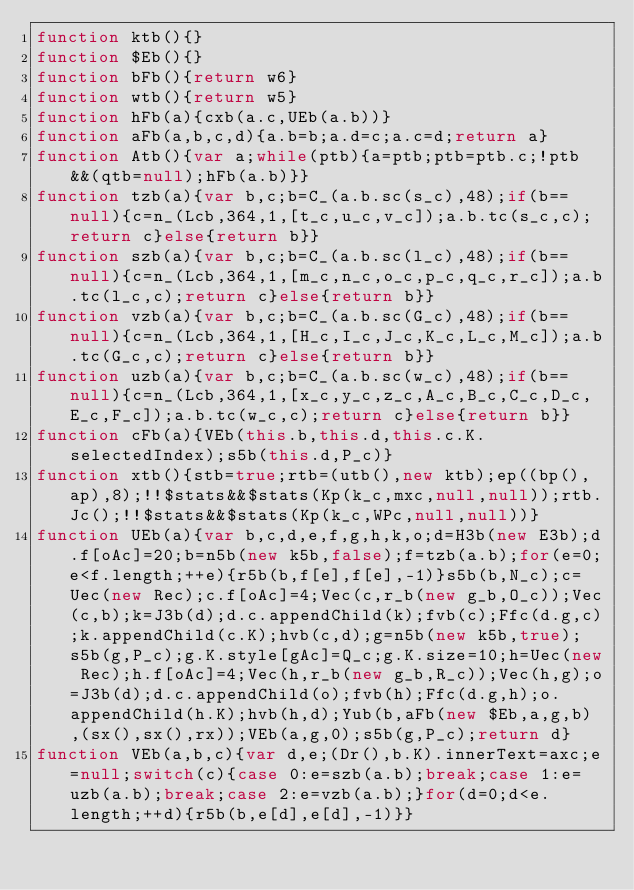Convert code to text. <code><loc_0><loc_0><loc_500><loc_500><_JavaScript_>function ktb(){}
function $Eb(){}
function bFb(){return w6}
function wtb(){return w5}
function hFb(a){cxb(a.c,UEb(a.b))}
function aFb(a,b,c,d){a.b=b;a.d=c;a.c=d;return a}
function Atb(){var a;while(ptb){a=ptb;ptb=ptb.c;!ptb&&(qtb=null);hFb(a.b)}}
function tzb(a){var b,c;b=C_(a.b.sc(s_c),48);if(b==null){c=n_(Lcb,364,1,[t_c,u_c,v_c]);a.b.tc(s_c,c);return c}else{return b}}
function szb(a){var b,c;b=C_(a.b.sc(l_c),48);if(b==null){c=n_(Lcb,364,1,[m_c,n_c,o_c,p_c,q_c,r_c]);a.b.tc(l_c,c);return c}else{return b}}
function vzb(a){var b,c;b=C_(a.b.sc(G_c),48);if(b==null){c=n_(Lcb,364,1,[H_c,I_c,J_c,K_c,L_c,M_c]);a.b.tc(G_c,c);return c}else{return b}}
function uzb(a){var b,c;b=C_(a.b.sc(w_c),48);if(b==null){c=n_(Lcb,364,1,[x_c,y_c,z_c,A_c,B_c,C_c,D_c,E_c,F_c]);a.b.tc(w_c,c);return c}else{return b}}
function cFb(a){VEb(this.b,this.d,this.c.K.selectedIndex);s5b(this.d,P_c)}
function xtb(){stb=true;rtb=(utb(),new ktb);ep((bp(),ap),8);!!$stats&&$stats(Kp(k_c,mxc,null,null));rtb.Jc();!!$stats&&$stats(Kp(k_c,WPc,null,null))}
function UEb(a){var b,c,d,e,f,g,h,k,o;d=H3b(new E3b);d.f[oAc]=20;b=n5b(new k5b,false);f=tzb(a.b);for(e=0;e<f.length;++e){r5b(b,f[e],f[e],-1)}s5b(b,N_c);c=Uec(new Rec);c.f[oAc]=4;Vec(c,r_b(new g_b,O_c));Vec(c,b);k=J3b(d);d.c.appendChild(k);fvb(c);Ffc(d.g,c);k.appendChild(c.K);hvb(c,d);g=n5b(new k5b,true);s5b(g,P_c);g.K.style[gAc]=Q_c;g.K.size=10;h=Uec(new Rec);h.f[oAc]=4;Vec(h,r_b(new g_b,R_c));Vec(h,g);o=J3b(d);d.c.appendChild(o);fvb(h);Ffc(d.g,h);o.appendChild(h.K);hvb(h,d);Yub(b,aFb(new $Eb,a,g,b),(sx(),sx(),rx));VEb(a,g,0);s5b(g,P_c);return d}
function VEb(a,b,c){var d,e;(Dr(),b.K).innerText=axc;e=null;switch(c){case 0:e=szb(a.b);break;case 1:e=uzb(a.b);break;case 2:e=vzb(a.b);}for(d=0;d<e.length;++d){r5b(b,e[d],e[d],-1)}}</code> 